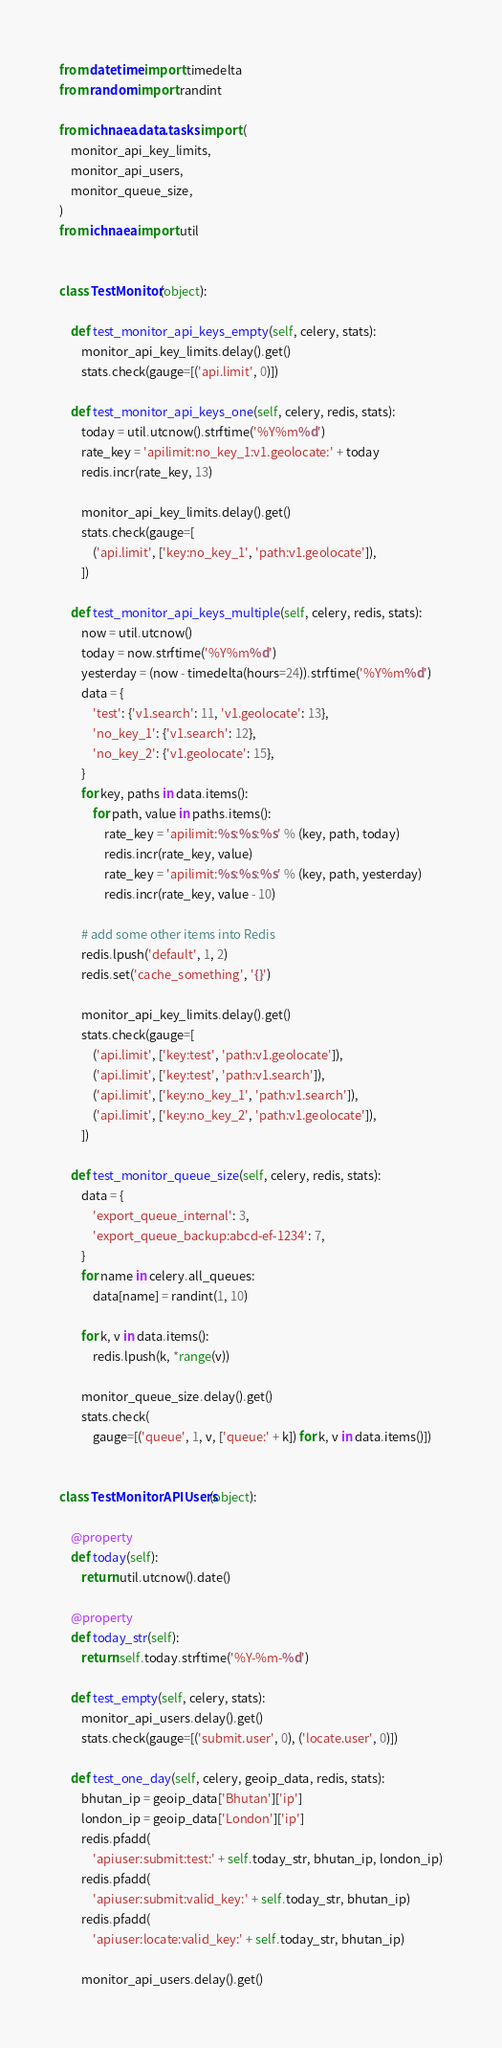Convert code to text. <code><loc_0><loc_0><loc_500><loc_500><_Python_>from datetime import timedelta
from random import randint

from ichnaea.data.tasks import (
    monitor_api_key_limits,
    monitor_api_users,
    monitor_queue_size,
)
from ichnaea import util


class TestMonitor(object):

    def test_monitor_api_keys_empty(self, celery, stats):
        monitor_api_key_limits.delay().get()
        stats.check(gauge=[('api.limit', 0)])

    def test_monitor_api_keys_one(self, celery, redis, stats):
        today = util.utcnow().strftime('%Y%m%d')
        rate_key = 'apilimit:no_key_1:v1.geolocate:' + today
        redis.incr(rate_key, 13)

        monitor_api_key_limits.delay().get()
        stats.check(gauge=[
            ('api.limit', ['key:no_key_1', 'path:v1.geolocate']),
        ])

    def test_monitor_api_keys_multiple(self, celery, redis, stats):
        now = util.utcnow()
        today = now.strftime('%Y%m%d')
        yesterday = (now - timedelta(hours=24)).strftime('%Y%m%d')
        data = {
            'test': {'v1.search': 11, 'v1.geolocate': 13},
            'no_key_1': {'v1.search': 12},
            'no_key_2': {'v1.geolocate': 15},
        }
        for key, paths in data.items():
            for path, value in paths.items():
                rate_key = 'apilimit:%s:%s:%s' % (key, path, today)
                redis.incr(rate_key, value)
                rate_key = 'apilimit:%s:%s:%s' % (key, path, yesterday)
                redis.incr(rate_key, value - 10)

        # add some other items into Redis
        redis.lpush('default', 1, 2)
        redis.set('cache_something', '{}')

        monitor_api_key_limits.delay().get()
        stats.check(gauge=[
            ('api.limit', ['key:test', 'path:v1.geolocate']),
            ('api.limit', ['key:test', 'path:v1.search']),
            ('api.limit', ['key:no_key_1', 'path:v1.search']),
            ('api.limit', ['key:no_key_2', 'path:v1.geolocate']),
        ])

    def test_monitor_queue_size(self, celery, redis, stats):
        data = {
            'export_queue_internal': 3,
            'export_queue_backup:abcd-ef-1234': 7,
        }
        for name in celery.all_queues:
            data[name] = randint(1, 10)

        for k, v in data.items():
            redis.lpush(k, *range(v))

        monitor_queue_size.delay().get()
        stats.check(
            gauge=[('queue', 1, v, ['queue:' + k]) for k, v in data.items()])


class TestMonitorAPIUsers(object):

    @property
    def today(self):
        return util.utcnow().date()

    @property
    def today_str(self):
        return self.today.strftime('%Y-%m-%d')

    def test_empty(self, celery, stats):
        monitor_api_users.delay().get()
        stats.check(gauge=[('submit.user', 0), ('locate.user', 0)])

    def test_one_day(self, celery, geoip_data, redis, stats):
        bhutan_ip = geoip_data['Bhutan']['ip']
        london_ip = geoip_data['London']['ip']
        redis.pfadd(
            'apiuser:submit:test:' + self.today_str, bhutan_ip, london_ip)
        redis.pfadd(
            'apiuser:submit:valid_key:' + self.today_str, bhutan_ip)
        redis.pfadd(
            'apiuser:locate:valid_key:' + self.today_str, bhutan_ip)

        monitor_api_users.delay().get()</code> 